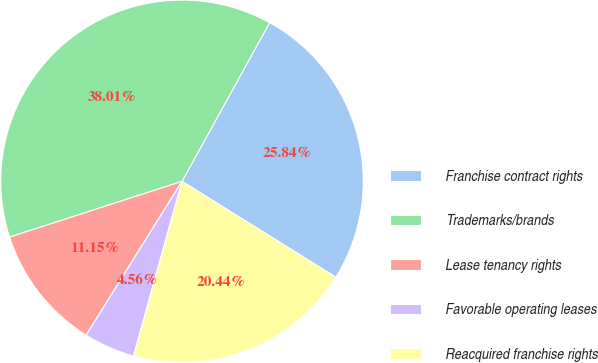Convert chart to OTSL. <chart><loc_0><loc_0><loc_500><loc_500><pie_chart><fcel>Franchise contract rights<fcel>Trademarks/brands<fcel>Lease tenancy rights<fcel>Favorable operating leases<fcel>Reacquired franchise rights<nl><fcel>25.84%<fcel>38.01%<fcel>11.15%<fcel>4.56%<fcel>20.44%<nl></chart> 